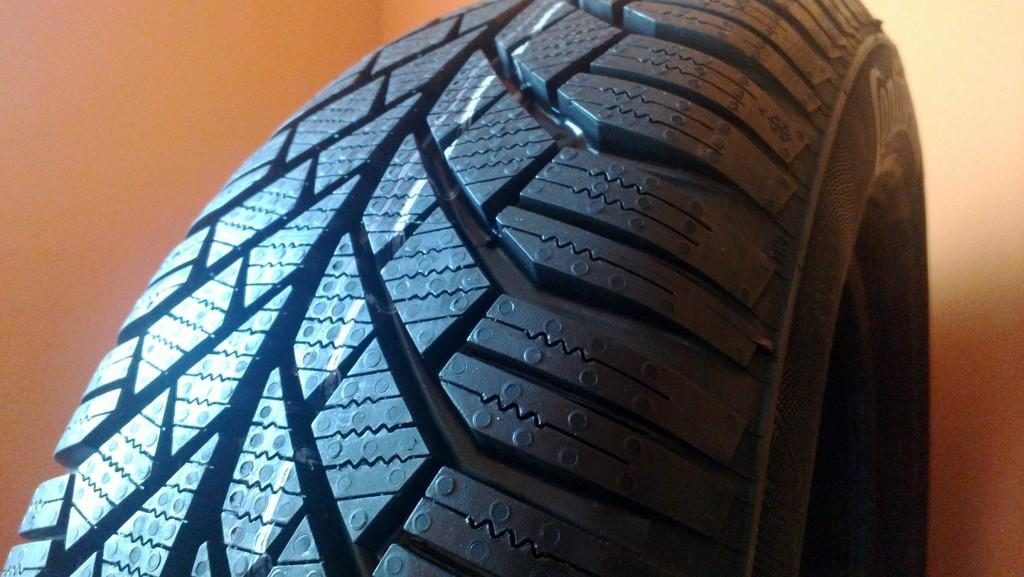What is the main subject of the image? The main subject of the image is a wheel of a vehicle. Can you describe the wheel in more detail? Unfortunately, the provided facts do not offer any additional details about the wheel. What type of vehicle might the wheel belong to? Without more information, it is impossible to determine the type of vehicle the wheel belongs to. How much tax is being paid on the mountain in the image? There is no mountain or tax mentioned in the image; it only features a wheel of a vehicle. 